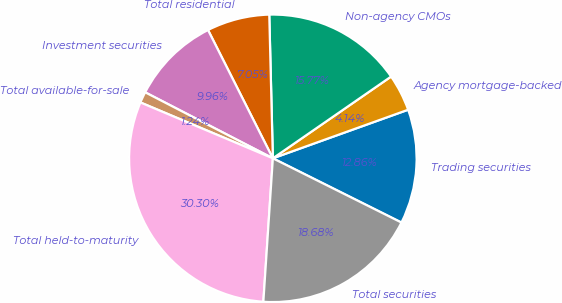<chart> <loc_0><loc_0><loc_500><loc_500><pie_chart><fcel>Trading securities<fcel>Agency mortgage-backed<fcel>Non-agency CMOs<fcel>Total residential<fcel>Investment securities<fcel>Total available-for-sale<fcel>Total held-to-maturity<fcel>Total securities<nl><fcel>12.86%<fcel>4.14%<fcel>15.77%<fcel>7.05%<fcel>9.96%<fcel>1.24%<fcel>30.3%<fcel>18.68%<nl></chart> 